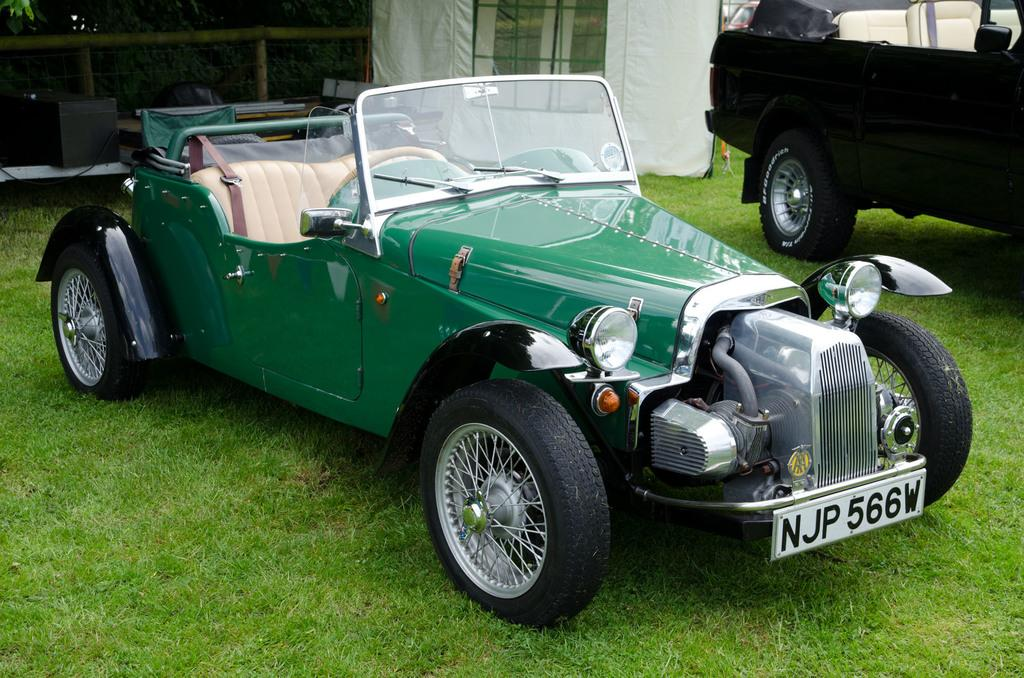What is the location of the vehicles in the image? The vehicles are parked on the grass in the image. What is located behind the vehicles? There is a tent, a fence, trees, and some objects behind the vehicles. Can you describe the objects behind the vehicles? Unfortunately, the provided facts do not give a detailed description of the objects behind the vehicles. What type of riddle is being discussed by the vehicles in the image? There is no indication in the image that the vehicles are discussing a riddle or any other topic. 